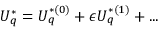<formula> <loc_0><loc_0><loc_500><loc_500>U _ { q } ^ { * } = U _ { q } ^ { * ( 0 ) } + \epsilon U _ { q } ^ { * ( 1 ) } + \dots</formula> 